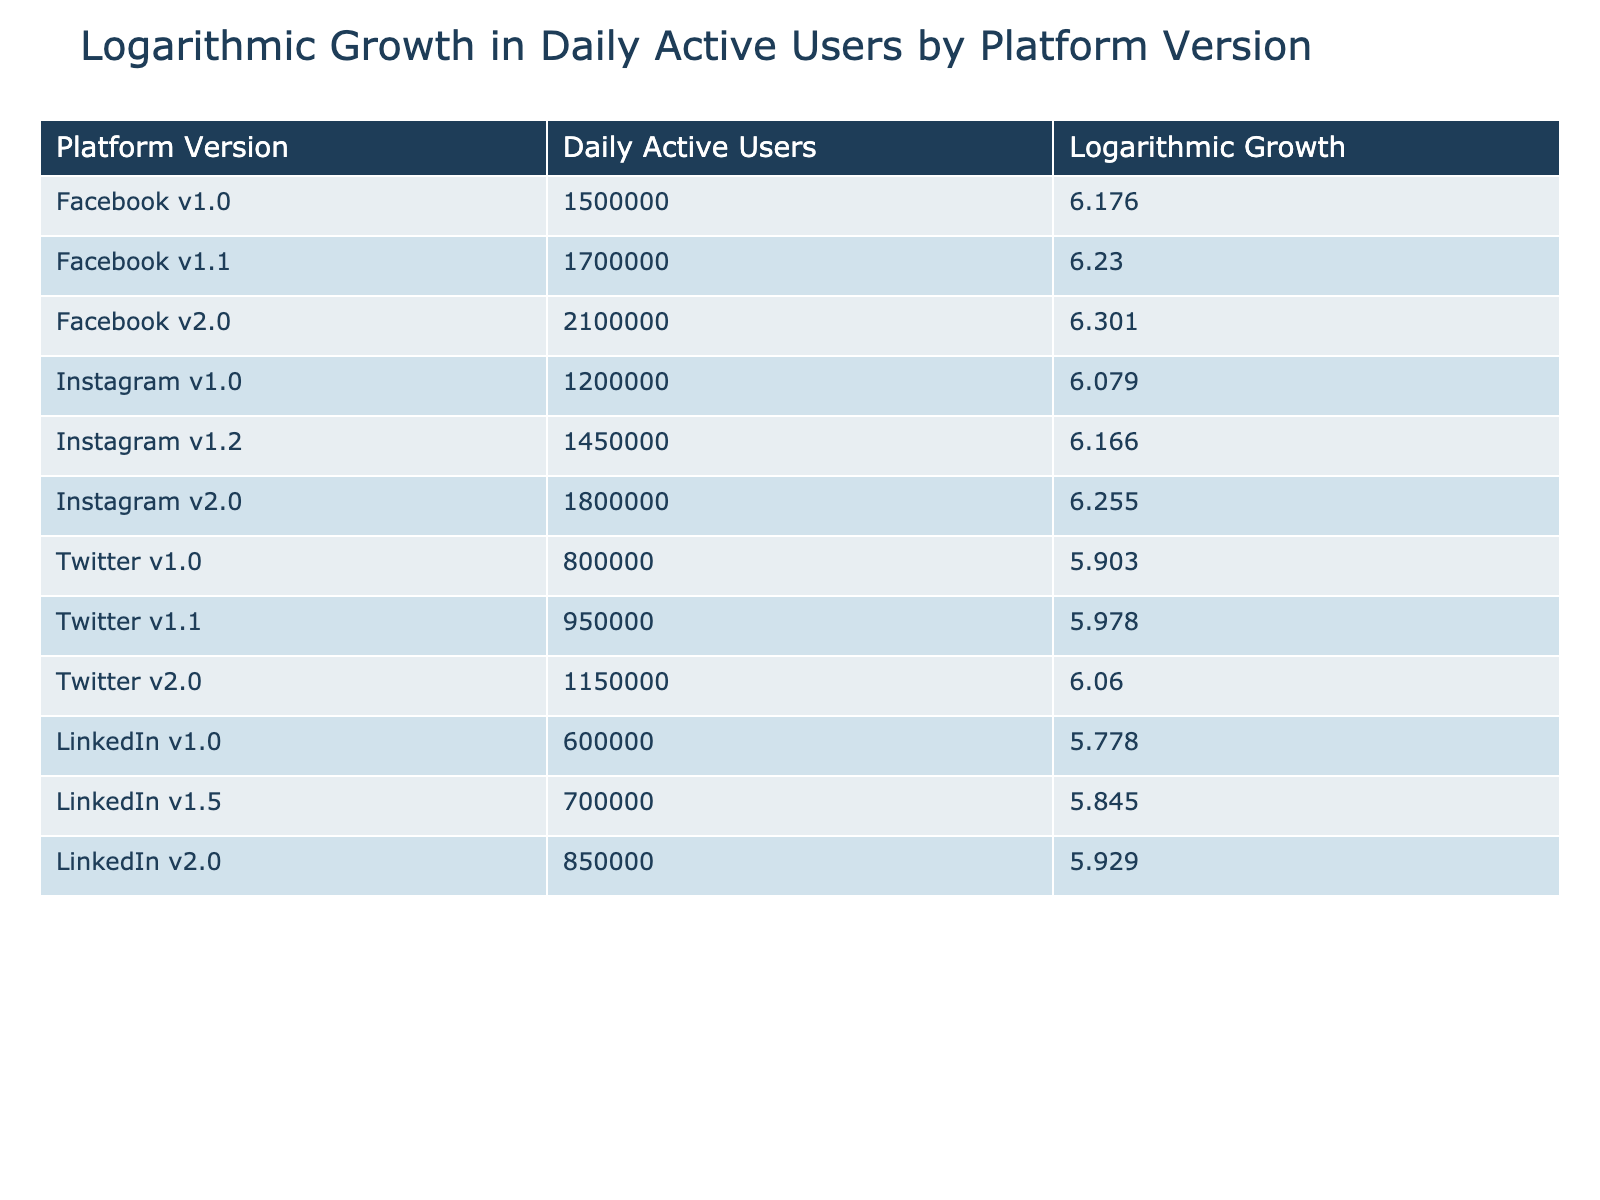What is the daily active user count for Facebook v2.0? Referring to the table, the entry for Facebook v2.0 shows a daily active user count of 2,100,000.
Answer: 2,100,000 Which platform version has the highest logarithmic growth? From the table, Facebook v2.0 has the highest logarithmic growth value of 6.301.
Answer: Facebook v2.0 What is the average daily active user count across all versions of Instagram? To find the average, we sum the daily active users for all Instagram versions: 1,200,000 + 1,450,000 + 1,800,000 = 4,450,000. Then we divide by 3 (the number of versions): 4,450,000 / 3 = 1,483,333.33.
Answer: 1,483,333.33 Does LinkedIn v2.0 have a logarithmic growth greater than 6? The table shows that LinkedIn v2.0 has a logarithmic growth of 5.929, which is less than 6, so the answer is no.
Answer: No Which platform version had a logarithmic growth value of 6.166? According to the table, Instagram v1.2 has a logarithmic growth value of 6.166.
Answer: Instagram v1.2 What is the difference in daily active users between the highest and lowest versions of Twitter? The highest daily active users for Twitter is 1,150,000 (Twitter v2.0) and the lowest is 800,000 (Twitter v1.0). The difference is 1,150,000 - 800,000 = 350,000.
Answer: 350,000 Are there any platform versions with a daily active user count of less than 1 million? Looking at the table, LinkedIn v1.0 and Twitter v1.0 have user counts below 1 million (600,000 and 800,000 respectively), making the statement true.
Answer: Yes Which platform had a logarithmic growth of 6.060? The table indicates that Twitter v2.0 has a logarithmic growth of 6.060.
Answer: Twitter v2.0 